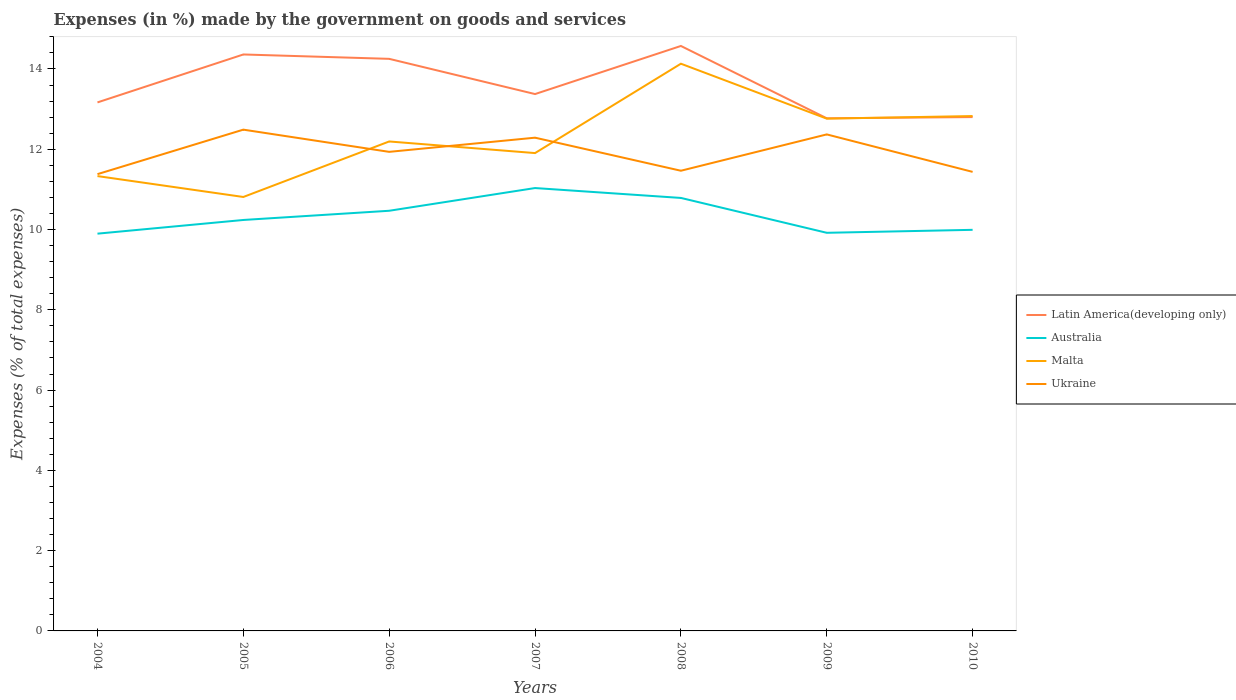How many different coloured lines are there?
Offer a terse response. 4. Does the line corresponding to Latin America(developing only) intersect with the line corresponding to Australia?
Offer a terse response. No. Across all years, what is the maximum percentage of expenses made by the government on goods and services in Australia?
Provide a short and direct response. 9.9. In which year was the percentage of expenses made by the government on goods and services in Malta maximum?
Ensure brevity in your answer.  2005. What is the total percentage of expenses made by the government on goods and services in Australia in the graph?
Provide a succinct answer. 0.79. What is the difference between the highest and the second highest percentage of expenses made by the government on goods and services in Latin America(developing only)?
Ensure brevity in your answer.  1.8. How many lines are there?
Your response must be concise. 4. Where does the legend appear in the graph?
Make the answer very short. Center right. What is the title of the graph?
Make the answer very short. Expenses (in %) made by the government on goods and services. Does "Antigua and Barbuda" appear as one of the legend labels in the graph?
Keep it short and to the point. No. What is the label or title of the X-axis?
Provide a succinct answer. Years. What is the label or title of the Y-axis?
Your answer should be very brief. Expenses (% of total expenses). What is the Expenses (% of total expenses) of Latin America(developing only) in 2004?
Provide a succinct answer. 13.17. What is the Expenses (% of total expenses) in Australia in 2004?
Make the answer very short. 9.9. What is the Expenses (% of total expenses) of Malta in 2004?
Your answer should be very brief. 11.33. What is the Expenses (% of total expenses) of Ukraine in 2004?
Give a very brief answer. 11.38. What is the Expenses (% of total expenses) of Latin America(developing only) in 2005?
Offer a very short reply. 14.36. What is the Expenses (% of total expenses) in Australia in 2005?
Your answer should be compact. 10.24. What is the Expenses (% of total expenses) of Malta in 2005?
Offer a very short reply. 10.81. What is the Expenses (% of total expenses) of Ukraine in 2005?
Ensure brevity in your answer.  12.49. What is the Expenses (% of total expenses) in Latin America(developing only) in 2006?
Provide a short and direct response. 14.25. What is the Expenses (% of total expenses) in Australia in 2006?
Your response must be concise. 10.47. What is the Expenses (% of total expenses) of Malta in 2006?
Offer a very short reply. 12.19. What is the Expenses (% of total expenses) of Ukraine in 2006?
Give a very brief answer. 11.94. What is the Expenses (% of total expenses) of Latin America(developing only) in 2007?
Ensure brevity in your answer.  13.38. What is the Expenses (% of total expenses) of Australia in 2007?
Your answer should be compact. 11.03. What is the Expenses (% of total expenses) in Malta in 2007?
Provide a succinct answer. 11.91. What is the Expenses (% of total expenses) of Ukraine in 2007?
Your answer should be compact. 12.29. What is the Expenses (% of total expenses) of Latin America(developing only) in 2008?
Your answer should be compact. 14.57. What is the Expenses (% of total expenses) in Australia in 2008?
Ensure brevity in your answer.  10.79. What is the Expenses (% of total expenses) of Malta in 2008?
Your answer should be compact. 14.13. What is the Expenses (% of total expenses) in Ukraine in 2008?
Make the answer very short. 11.47. What is the Expenses (% of total expenses) in Latin America(developing only) in 2009?
Give a very brief answer. 12.77. What is the Expenses (% of total expenses) of Australia in 2009?
Offer a very short reply. 9.92. What is the Expenses (% of total expenses) of Malta in 2009?
Offer a terse response. 12.76. What is the Expenses (% of total expenses) in Ukraine in 2009?
Give a very brief answer. 12.37. What is the Expenses (% of total expenses) in Latin America(developing only) in 2010?
Your response must be concise. 12.8. What is the Expenses (% of total expenses) of Australia in 2010?
Your response must be concise. 9.99. What is the Expenses (% of total expenses) of Malta in 2010?
Your answer should be compact. 12.83. What is the Expenses (% of total expenses) in Ukraine in 2010?
Keep it short and to the point. 11.44. Across all years, what is the maximum Expenses (% of total expenses) of Latin America(developing only)?
Your response must be concise. 14.57. Across all years, what is the maximum Expenses (% of total expenses) in Australia?
Offer a terse response. 11.03. Across all years, what is the maximum Expenses (% of total expenses) in Malta?
Ensure brevity in your answer.  14.13. Across all years, what is the maximum Expenses (% of total expenses) of Ukraine?
Your answer should be compact. 12.49. Across all years, what is the minimum Expenses (% of total expenses) of Latin America(developing only)?
Give a very brief answer. 12.77. Across all years, what is the minimum Expenses (% of total expenses) in Australia?
Keep it short and to the point. 9.9. Across all years, what is the minimum Expenses (% of total expenses) in Malta?
Provide a succinct answer. 10.81. Across all years, what is the minimum Expenses (% of total expenses) of Ukraine?
Provide a succinct answer. 11.38. What is the total Expenses (% of total expenses) of Latin America(developing only) in the graph?
Give a very brief answer. 95.3. What is the total Expenses (% of total expenses) of Australia in the graph?
Offer a terse response. 72.34. What is the total Expenses (% of total expenses) of Malta in the graph?
Make the answer very short. 85.96. What is the total Expenses (% of total expenses) in Ukraine in the graph?
Your response must be concise. 83.36. What is the difference between the Expenses (% of total expenses) of Latin America(developing only) in 2004 and that in 2005?
Offer a very short reply. -1.19. What is the difference between the Expenses (% of total expenses) in Australia in 2004 and that in 2005?
Provide a short and direct response. -0.34. What is the difference between the Expenses (% of total expenses) in Malta in 2004 and that in 2005?
Your answer should be very brief. 0.52. What is the difference between the Expenses (% of total expenses) in Ukraine in 2004 and that in 2005?
Offer a terse response. -1.11. What is the difference between the Expenses (% of total expenses) of Latin America(developing only) in 2004 and that in 2006?
Give a very brief answer. -1.09. What is the difference between the Expenses (% of total expenses) of Australia in 2004 and that in 2006?
Offer a terse response. -0.57. What is the difference between the Expenses (% of total expenses) of Malta in 2004 and that in 2006?
Your answer should be compact. -0.86. What is the difference between the Expenses (% of total expenses) of Ukraine in 2004 and that in 2006?
Your answer should be very brief. -0.56. What is the difference between the Expenses (% of total expenses) of Latin America(developing only) in 2004 and that in 2007?
Offer a very short reply. -0.21. What is the difference between the Expenses (% of total expenses) in Australia in 2004 and that in 2007?
Give a very brief answer. -1.14. What is the difference between the Expenses (% of total expenses) of Malta in 2004 and that in 2007?
Provide a short and direct response. -0.57. What is the difference between the Expenses (% of total expenses) in Ukraine in 2004 and that in 2007?
Provide a short and direct response. -0.91. What is the difference between the Expenses (% of total expenses) in Latin America(developing only) in 2004 and that in 2008?
Make the answer very short. -1.41. What is the difference between the Expenses (% of total expenses) of Australia in 2004 and that in 2008?
Your answer should be compact. -0.89. What is the difference between the Expenses (% of total expenses) of Malta in 2004 and that in 2008?
Your answer should be very brief. -2.8. What is the difference between the Expenses (% of total expenses) in Ukraine in 2004 and that in 2008?
Ensure brevity in your answer.  -0.09. What is the difference between the Expenses (% of total expenses) of Latin America(developing only) in 2004 and that in 2009?
Give a very brief answer. 0.4. What is the difference between the Expenses (% of total expenses) of Australia in 2004 and that in 2009?
Offer a very short reply. -0.02. What is the difference between the Expenses (% of total expenses) of Malta in 2004 and that in 2009?
Give a very brief answer. -1.43. What is the difference between the Expenses (% of total expenses) in Ukraine in 2004 and that in 2009?
Your response must be concise. -0.99. What is the difference between the Expenses (% of total expenses) of Latin America(developing only) in 2004 and that in 2010?
Offer a terse response. 0.37. What is the difference between the Expenses (% of total expenses) of Australia in 2004 and that in 2010?
Offer a very short reply. -0.1. What is the difference between the Expenses (% of total expenses) of Malta in 2004 and that in 2010?
Offer a terse response. -1.5. What is the difference between the Expenses (% of total expenses) in Ukraine in 2004 and that in 2010?
Your answer should be very brief. -0.06. What is the difference between the Expenses (% of total expenses) in Latin America(developing only) in 2005 and that in 2006?
Offer a very short reply. 0.11. What is the difference between the Expenses (% of total expenses) of Australia in 2005 and that in 2006?
Your answer should be very brief. -0.23. What is the difference between the Expenses (% of total expenses) of Malta in 2005 and that in 2006?
Offer a very short reply. -1.38. What is the difference between the Expenses (% of total expenses) in Ukraine in 2005 and that in 2006?
Provide a short and direct response. 0.55. What is the difference between the Expenses (% of total expenses) of Latin America(developing only) in 2005 and that in 2007?
Keep it short and to the point. 0.99. What is the difference between the Expenses (% of total expenses) of Australia in 2005 and that in 2007?
Offer a very short reply. -0.8. What is the difference between the Expenses (% of total expenses) in Malta in 2005 and that in 2007?
Offer a very short reply. -1.09. What is the difference between the Expenses (% of total expenses) in Ukraine in 2005 and that in 2007?
Offer a terse response. 0.2. What is the difference between the Expenses (% of total expenses) in Latin America(developing only) in 2005 and that in 2008?
Your response must be concise. -0.21. What is the difference between the Expenses (% of total expenses) of Australia in 2005 and that in 2008?
Provide a succinct answer. -0.55. What is the difference between the Expenses (% of total expenses) in Malta in 2005 and that in 2008?
Provide a succinct answer. -3.32. What is the difference between the Expenses (% of total expenses) of Ukraine in 2005 and that in 2008?
Provide a short and direct response. 1.02. What is the difference between the Expenses (% of total expenses) of Latin America(developing only) in 2005 and that in 2009?
Provide a succinct answer. 1.59. What is the difference between the Expenses (% of total expenses) of Australia in 2005 and that in 2009?
Offer a terse response. 0.32. What is the difference between the Expenses (% of total expenses) in Malta in 2005 and that in 2009?
Make the answer very short. -1.95. What is the difference between the Expenses (% of total expenses) of Ukraine in 2005 and that in 2009?
Provide a short and direct response. 0.12. What is the difference between the Expenses (% of total expenses) in Latin America(developing only) in 2005 and that in 2010?
Offer a terse response. 1.56. What is the difference between the Expenses (% of total expenses) in Australia in 2005 and that in 2010?
Provide a short and direct response. 0.25. What is the difference between the Expenses (% of total expenses) in Malta in 2005 and that in 2010?
Your answer should be very brief. -2.02. What is the difference between the Expenses (% of total expenses) of Ukraine in 2005 and that in 2010?
Make the answer very short. 1.05. What is the difference between the Expenses (% of total expenses) of Latin America(developing only) in 2006 and that in 2007?
Your answer should be compact. 0.88. What is the difference between the Expenses (% of total expenses) of Australia in 2006 and that in 2007?
Keep it short and to the point. -0.57. What is the difference between the Expenses (% of total expenses) of Malta in 2006 and that in 2007?
Provide a succinct answer. 0.29. What is the difference between the Expenses (% of total expenses) of Ukraine in 2006 and that in 2007?
Offer a terse response. -0.35. What is the difference between the Expenses (% of total expenses) of Latin America(developing only) in 2006 and that in 2008?
Provide a short and direct response. -0.32. What is the difference between the Expenses (% of total expenses) of Australia in 2006 and that in 2008?
Make the answer very short. -0.32. What is the difference between the Expenses (% of total expenses) of Malta in 2006 and that in 2008?
Ensure brevity in your answer.  -1.94. What is the difference between the Expenses (% of total expenses) of Ukraine in 2006 and that in 2008?
Provide a short and direct response. 0.47. What is the difference between the Expenses (% of total expenses) of Latin America(developing only) in 2006 and that in 2009?
Provide a short and direct response. 1.48. What is the difference between the Expenses (% of total expenses) in Australia in 2006 and that in 2009?
Ensure brevity in your answer.  0.55. What is the difference between the Expenses (% of total expenses) of Malta in 2006 and that in 2009?
Your answer should be compact. -0.57. What is the difference between the Expenses (% of total expenses) in Ukraine in 2006 and that in 2009?
Keep it short and to the point. -0.43. What is the difference between the Expenses (% of total expenses) of Latin America(developing only) in 2006 and that in 2010?
Ensure brevity in your answer.  1.45. What is the difference between the Expenses (% of total expenses) of Australia in 2006 and that in 2010?
Offer a very short reply. 0.47. What is the difference between the Expenses (% of total expenses) of Malta in 2006 and that in 2010?
Your response must be concise. -0.63. What is the difference between the Expenses (% of total expenses) of Ukraine in 2006 and that in 2010?
Offer a terse response. 0.5. What is the difference between the Expenses (% of total expenses) in Latin America(developing only) in 2007 and that in 2008?
Offer a terse response. -1.2. What is the difference between the Expenses (% of total expenses) in Australia in 2007 and that in 2008?
Your answer should be compact. 0.25. What is the difference between the Expenses (% of total expenses) of Malta in 2007 and that in 2008?
Provide a short and direct response. -2.23. What is the difference between the Expenses (% of total expenses) in Ukraine in 2007 and that in 2008?
Provide a short and direct response. 0.82. What is the difference between the Expenses (% of total expenses) of Latin America(developing only) in 2007 and that in 2009?
Make the answer very short. 0.6. What is the difference between the Expenses (% of total expenses) of Australia in 2007 and that in 2009?
Your response must be concise. 1.12. What is the difference between the Expenses (% of total expenses) of Malta in 2007 and that in 2009?
Offer a very short reply. -0.86. What is the difference between the Expenses (% of total expenses) of Ukraine in 2007 and that in 2009?
Offer a terse response. -0.08. What is the difference between the Expenses (% of total expenses) of Latin America(developing only) in 2007 and that in 2010?
Your answer should be compact. 0.57. What is the difference between the Expenses (% of total expenses) in Australia in 2007 and that in 2010?
Your answer should be compact. 1.04. What is the difference between the Expenses (% of total expenses) of Malta in 2007 and that in 2010?
Your response must be concise. -0.92. What is the difference between the Expenses (% of total expenses) in Ukraine in 2007 and that in 2010?
Provide a succinct answer. 0.85. What is the difference between the Expenses (% of total expenses) in Latin America(developing only) in 2008 and that in 2009?
Make the answer very short. 1.8. What is the difference between the Expenses (% of total expenses) in Australia in 2008 and that in 2009?
Keep it short and to the point. 0.87. What is the difference between the Expenses (% of total expenses) of Malta in 2008 and that in 2009?
Make the answer very short. 1.37. What is the difference between the Expenses (% of total expenses) of Ukraine in 2008 and that in 2009?
Offer a terse response. -0.91. What is the difference between the Expenses (% of total expenses) of Latin America(developing only) in 2008 and that in 2010?
Offer a terse response. 1.77. What is the difference between the Expenses (% of total expenses) in Australia in 2008 and that in 2010?
Your response must be concise. 0.79. What is the difference between the Expenses (% of total expenses) in Malta in 2008 and that in 2010?
Your answer should be very brief. 1.3. What is the difference between the Expenses (% of total expenses) in Ukraine in 2008 and that in 2010?
Your response must be concise. 0.03. What is the difference between the Expenses (% of total expenses) of Latin America(developing only) in 2009 and that in 2010?
Make the answer very short. -0.03. What is the difference between the Expenses (% of total expenses) of Australia in 2009 and that in 2010?
Ensure brevity in your answer.  -0.07. What is the difference between the Expenses (% of total expenses) in Malta in 2009 and that in 2010?
Ensure brevity in your answer.  -0.06. What is the difference between the Expenses (% of total expenses) in Ukraine in 2009 and that in 2010?
Ensure brevity in your answer.  0.93. What is the difference between the Expenses (% of total expenses) of Latin America(developing only) in 2004 and the Expenses (% of total expenses) of Australia in 2005?
Your answer should be compact. 2.93. What is the difference between the Expenses (% of total expenses) of Latin America(developing only) in 2004 and the Expenses (% of total expenses) of Malta in 2005?
Offer a very short reply. 2.36. What is the difference between the Expenses (% of total expenses) of Latin America(developing only) in 2004 and the Expenses (% of total expenses) of Ukraine in 2005?
Keep it short and to the point. 0.68. What is the difference between the Expenses (% of total expenses) in Australia in 2004 and the Expenses (% of total expenses) in Malta in 2005?
Your answer should be compact. -0.91. What is the difference between the Expenses (% of total expenses) in Australia in 2004 and the Expenses (% of total expenses) in Ukraine in 2005?
Your answer should be compact. -2.59. What is the difference between the Expenses (% of total expenses) of Malta in 2004 and the Expenses (% of total expenses) of Ukraine in 2005?
Keep it short and to the point. -1.16. What is the difference between the Expenses (% of total expenses) of Latin America(developing only) in 2004 and the Expenses (% of total expenses) of Australia in 2006?
Offer a terse response. 2.7. What is the difference between the Expenses (% of total expenses) in Latin America(developing only) in 2004 and the Expenses (% of total expenses) in Malta in 2006?
Ensure brevity in your answer.  0.97. What is the difference between the Expenses (% of total expenses) in Latin America(developing only) in 2004 and the Expenses (% of total expenses) in Ukraine in 2006?
Your answer should be very brief. 1.23. What is the difference between the Expenses (% of total expenses) in Australia in 2004 and the Expenses (% of total expenses) in Malta in 2006?
Make the answer very short. -2.3. What is the difference between the Expenses (% of total expenses) of Australia in 2004 and the Expenses (% of total expenses) of Ukraine in 2006?
Give a very brief answer. -2.04. What is the difference between the Expenses (% of total expenses) of Malta in 2004 and the Expenses (% of total expenses) of Ukraine in 2006?
Your answer should be compact. -0.6. What is the difference between the Expenses (% of total expenses) of Latin America(developing only) in 2004 and the Expenses (% of total expenses) of Australia in 2007?
Your response must be concise. 2.13. What is the difference between the Expenses (% of total expenses) of Latin America(developing only) in 2004 and the Expenses (% of total expenses) of Malta in 2007?
Give a very brief answer. 1.26. What is the difference between the Expenses (% of total expenses) in Latin America(developing only) in 2004 and the Expenses (% of total expenses) in Ukraine in 2007?
Keep it short and to the point. 0.88. What is the difference between the Expenses (% of total expenses) in Australia in 2004 and the Expenses (% of total expenses) in Malta in 2007?
Make the answer very short. -2.01. What is the difference between the Expenses (% of total expenses) in Australia in 2004 and the Expenses (% of total expenses) in Ukraine in 2007?
Offer a terse response. -2.39. What is the difference between the Expenses (% of total expenses) in Malta in 2004 and the Expenses (% of total expenses) in Ukraine in 2007?
Your answer should be compact. -0.96. What is the difference between the Expenses (% of total expenses) of Latin America(developing only) in 2004 and the Expenses (% of total expenses) of Australia in 2008?
Keep it short and to the point. 2.38. What is the difference between the Expenses (% of total expenses) of Latin America(developing only) in 2004 and the Expenses (% of total expenses) of Malta in 2008?
Make the answer very short. -0.96. What is the difference between the Expenses (% of total expenses) of Latin America(developing only) in 2004 and the Expenses (% of total expenses) of Ukraine in 2008?
Your answer should be compact. 1.7. What is the difference between the Expenses (% of total expenses) in Australia in 2004 and the Expenses (% of total expenses) in Malta in 2008?
Provide a short and direct response. -4.23. What is the difference between the Expenses (% of total expenses) in Australia in 2004 and the Expenses (% of total expenses) in Ukraine in 2008?
Your answer should be very brief. -1.57. What is the difference between the Expenses (% of total expenses) in Malta in 2004 and the Expenses (% of total expenses) in Ukraine in 2008?
Make the answer very short. -0.13. What is the difference between the Expenses (% of total expenses) of Latin America(developing only) in 2004 and the Expenses (% of total expenses) of Australia in 2009?
Offer a very short reply. 3.25. What is the difference between the Expenses (% of total expenses) of Latin America(developing only) in 2004 and the Expenses (% of total expenses) of Malta in 2009?
Offer a very short reply. 0.4. What is the difference between the Expenses (% of total expenses) of Latin America(developing only) in 2004 and the Expenses (% of total expenses) of Ukraine in 2009?
Your answer should be compact. 0.8. What is the difference between the Expenses (% of total expenses) of Australia in 2004 and the Expenses (% of total expenses) of Malta in 2009?
Your answer should be compact. -2.87. What is the difference between the Expenses (% of total expenses) of Australia in 2004 and the Expenses (% of total expenses) of Ukraine in 2009?
Provide a short and direct response. -2.47. What is the difference between the Expenses (% of total expenses) of Malta in 2004 and the Expenses (% of total expenses) of Ukraine in 2009?
Keep it short and to the point. -1.04. What is the difference between the Expenses (% of total expenses) in Latin America(developing only) in 2004 and the Expenses (% of total expenses) in Australia in 2010?
Offer a terse response. 3.17. What is the difference between the Expenses (% of total expenses) in Latin America(developing only) in 2004 and the Expenses (% of total expenses) in Malta in 2010?
Your response must be concise. 0.34. What is the difference between the Expenses (% of total expenses) of Latin America(developing only) in 2004 and the Expenses (% of total expenses) of Ukraine in 2010?
Give a very brief answer. 1.73. What is the difference between the Expenses (% of total expenses) of Australia in 2004 and the Expenses (% of total expenses) of Malta in 2010?
Provide a succinct answer. -2.93. What is the difference between the Expenses (% of total expenses) of Australia in 2004 and the Expenses (% of total expenses) of Ukraine in 2010?
Keep it short and to the point. -1.54. What is the difference between the Expenses (% of total expenses) of Malta in 2004 and the Expenses (% of total expenses) of Ukraine in 2010?
Your response must be concise. -0.1. What is the difference between the Expenses (% of total expenses) of Latin America(developing only) in 2005 and the Expenses (% of total expenses) of Australia in 2006?
Your answer should be very brief. 3.89. What is the difference between the Expenses (% of total expenses) of Latin America(developing only) in 2005 and the Expenses (% of total expenses) of Malta in 2006?
Provide a short and direct response. 2.17. What is the difference between the Expenses (% of total expenses) of Latin America(developing only) in 2005 and the Expenses (% of total expenses) of Ukraine in 2006?
Provide a succinct answer. 2.43. What is the difference between the Expenses (% of total expenses) in Australia in 2005 and the Expenses (% of total expenses) in Malta in 2006?
Provide a short and direct response. -1.96. What is the difference between the Expenses (% of total expenses) of Australia in 2005 and the Expenses (% of total expenses) of Ukraine in 2006?
Ensure brevity in your answer.  -1.7. What is the difference between the Expenses (% of total expenses) of Malta in 2005 and the Expenses (% of total expenses) of Ukraine in 2006?
Your answer should be compact. -1.12. What is the difference between the Expenses (% of total expenses) in Latin America(developing only) in 2005 and the Expenses (% of total expenses) in Australia in 2007?
Your answer should be very brief. 3.33. What is the difference between the Expenses (% of total expenses) in Latin America(developing only) in 2005 and the Expenses (% of total expenses) in Malta in 2007?
Offer a very short reply. 2.46. What is the difference between the Expenses (% of total expenses) of Latin America(developing only) in 2005 and the Expenses (% of total expenses) of Ukraine in 2007?
Offer a terse response. 2.07. What is the difference between the Expenses (% of total expenses) in Australia in 2005 and the Expenses (% of total expenses) in Malta in 2007?
Provide a short and direct response. -1.67. What is the difference between the Expenses (% of total expenses) in Australia in 2005 and the Expenses (% of total expenses) in Ukraine in 2007?
Ensure brevity in your answer.  -2.05. What is the difference between the Expenses (% of total expenses) in Malta in 2005 and the Expenses (% of total expenses) in Ukraine in 2007?
Provide a short and direct response. -1.48. What is the difference between the Expenses (% of total expenses) in Latin America(developing only) in 2005 and the Expenses (% of total expenses) in Australia in 2008?
Your response must be concise. 3.57. What is the difference between the Expenses (% of total expenses) in Latin America(developing only) in 2005 and the Expenses (% of total expenses) in Malta in 2008?
Offer a very short reply. 0.23. What is the difference between the Expenses (% of total expenses) of Latin America(developing only) in 2005 and the Expenses (% of total expenses) of Ukraine in 2008?
Make the answer very short. 2.9. What is the difference between the Expenses (% of total expenses) of Australia in 2005 and the Expenses (% of total expenses) of Malta in 2008?
Ensure brevity in your answer.  -3.89. What is the difference between the Expenses (% of total expenses) of Australia in 2005 and the Expenses (% of total expenses) of Ukraine in 2008?
Provide a succinct answer. -1.23. What is the difference between the Expenses (% of total expenses) of Malta in 2005 and the Expenses (% of total expenses) of Ukraine in 2008?
Give a very brief answer. -0.65. What is the difference between the Expenses (% of total expenses) in Latin America(developing only) in 2005 and the Expenses (% of total expenses) in Australia in 2009?
Ensure brevity in your answer.  4.44. What is the difference between the Expenses (% of total expenses) of Latin America(developing only) in 2005 and the Expenses (% of total expenses) of Malta in 2009?
Provide a short and direct response. 1.6. What is the difference between the Expenses (% of total expenses) in Latin America(developing only) in 2005 and the Expenses (% of total expenses) in Ukraine in 2009?
Make the answer very short. 1.99. What is the difference between the Expenses (% of total expenses) in Australia in 2005 and the Expenses (% of total expenses) in Malta in 2009?
Offer a very short reply. -2.52. What is the difference between the Expenses (% of total expenses) of Australia in 2005 and the Expenses (% of total expenses) of Ukraine in 2009?
Your answer should be compact. -2.13. What is the difference between the Expenses (% of total expenses) of Malta in 2005 and the Expenses (% of total expenses) of Ukraine in 2009?
Offer a terse response. -1.56. What is the difference between the Expenses (% of total expenses) of Latin America(developing only) in 2005 and the Expenses (% of total expenses) of Australia in 2010?
Your response must be concise. 4.37. What is the difference between the Expenses (% of total expenses) of Latin America(developing only) in 2005 and the Expenses (% of total expenses) of Malta in 2010?
Ensure brevity in your answer.  1.53. What is the difference between the Expenses (% of total expenses) in Latin America(developing only) in 2005 and the Expenses (% of total expenses) in Ukraine in 2010?
Ensure brevity in your answer.  2.93. What is the difference between the Expenses (% of total expenses) of Australia in 2005 and the Expenses (% of total expenses) of Malta in 2010?
Your answer should be compact. -2.59. What is the difference between the Expenses (% of total expenses) of Australia in 2005 and the Expenses (% of total expenses) of Ukraine in 2010?
Give a very brief answer. -1.2. What is the difference between the Expenses (% of total expenses) in Malta in 2005 and the Expenses (% of total expenses) in Ukraine in 2010?
Offer a very short reply. -0.63. What is the difference between the Expenses (% of total expenses) in Latin America(developing only) in 2006 and the Expenses (% of total expenses) in Australia in 2007?
Keep it short and to the point. 3.22. What is the difference between the Expenses (% of total expenses) of Latin America(developing only) in 2006 and the Expenses (% of total expenses) of Malta in 2007?
Provide a short and direct response. 2.35. What is the difference between the Expenses (% of total expenses) in Latin America(developing only) in 2006 and the Expenses (% of total expenses) in Ukraine in 2007?
Keep it short and to the point. 1.96. What is the difference between the Expenses (% of total expenses) of Australia in 2006 and the Expenses (% of total expenses) of Malta in 2007?
Provide a short and direct response. -1.44. What is the difference between the Expenses (% of total expenses) of Australia in 2006 and the Expenses (% of total expenses) of Ukraine in 2007?
Offer a very short reply. -1.82. What is the difference between the Expenses (% of total expenses) of Malta in 2006 and the Expenses (% of total expenses) of Ukraine in 2007?
Offer a very short reply. -0.09. What is the difference between the Expenses (% of total expenses) of Latin America(developing only) in 2006 and the Expenses (% of total expenses) of Australia in 2008?
Make the answer very short. 3.47. What is the difference between the Expenses (% of total expenses) in Latin America(developing only) in 2006 and the Expenses (% of total expenses) in Malta in 2008?
Give a very brief answer. 0.12. What is the difference between the Expenses (% of total expenses) of Latin America(developing only) in 2006 and the Expenses (% of total expenses) of Ukraine in 2008?
Offer a terse response. 2.79. What is the difference between the Expenses (% of total expenses) in Australia in 2006 and the Expenses (% of total expenses) in Malta in 2008?
Your answer should be very brief. -3.66. What is the difference between the Expenses (% of total expenses) of Australia in 2006 and the Expenses (% of total expenses) of Ukraine in 2008?
Offer a terse response. -1. What is the difference between the Expenses (% of total expenses) in Malta in 2006 and the Expenses (% of total expenses) in Ukraine in 2008?
Your answer should be compact. 0.73. What is the difference between the Expenses (% of total expenses) in Latin America(developing only) in 2006 and the Expenses (% of total expenses) in Australia in 2009?
Offer a terse response. 4.33. What is the difference between the Expenses (% of total expenses) in Latin America(developing only) in 2006 and the Expenses (% of total expenses) in Malta in 2009?
Give a very brief answer. 1.49. What is the difference between the Expenses (% of total expenses) in Latin America(developing only) in 2006 and the Expenses (% of total expenses) in Ukraine in 2009?
Give a very brief answer. 1.88. What is the difference between the Expenses (% of total expenses) of Australia in 2006 and the Expenses (% of total expenses) of Malta in 2009?
Provide a succinct answer. -2.3. What is the difference between the Expenses (% of total expenses) in Australia in 2006 and the Expenses (% of total expenses) in Ukraine in 2009?
Offer a terse response. -1.9. What is the difference between the Expenses (% of total expenses) of Malta in 2006 and the Expenses (% of total expenses) of Ukraine in 2009?
Your answer should be compact. -0.18. What is the difference between the Expenses (% of total expenses) of Latin America(developing only) in 2006 and the Expenses (% of total expenses) of Australia in 2010?
Your response must be concise. 4.26. What is the difference between the Expenses (% of total expenses) of Latin America(developing only) in 2006 and the Expenses (% of total expenses) of Malta in 2010?
Offer a very short reply. 1.43. What is the difference between the Expenses (% of total expenses) of Latin America(developing only) in 2006 and the Expenses (% of total expenses) of Ukraine in 2010?
Ensure brevity in your answer.  2.82. What is the difference between the Expenses (% of total expenses) in Australia in 2006 and the Expenses (% of total expenses) in Malta in 2010?
Keep it short and to the point. -2.36. What is the difference between the Expenses (% of total expenses) in Australia in 2006 and the Expenses (% of total expenses) in Ukraine in 2010?
Provide a succinct answer. -0.97. What is the difference between the Expenses (% of total expenses) of Malta in 2006 and the Expenses (% of total expenses) of Ukraine in 2010?
Your answer should be compact. 0.76. What is the difference between the Expenses (% of total expenses) in Latin America(developing only) in 2007 and the Expenses (% of total expenses) in Australia in 2008?
Give a very brief answer. 2.59. What is the difference between the Expenses (% of total expenses) of Latin America(developing only) in 2007 and the Expenses (% of total expenses) of Malta in 2008?
Offer a very short reply. -0.76. What is the difference between the Expenses (% of total expenses) in Latin America(developing only) in 2007 and the Expenses (% of total expenses) in Ukraine in 2008?
Provide a succinct answer. 1.91. What is the difference between the Expenses (% of total expenses) of Australia in 2007 and the Expenses (% of total expenses) of Malta in 2008?
Offer a terse response. -3.1. What is the difference between the Expenses (% of total expenses) in Australia in 2007 and the Expenses (% of total expenses) in Ukraine in 2008?
Offer a very short reply. -0.43. What is the difference between the Expenses (% of total expenses) of Malta in 2007 and the Expenses (% of total expenses) of Ukraine in 2008?
Offer a very short reply. 0.44. What is the difference between the Expenses (% of total expenses) of Latin America(developing only) in 2007 and the Expenses (% of total expenses) of Australia in 2009?
Provide a succinct answer. 3.46. What is the difference between the Expenses (% of total expenses) in Latin America(developing only) in 2007 and the Expenses (% of total expenses) in Malta in 2009?
Your answer should be very brief. 0.61. What is the difference between the Expenses (% of total expenses) in Australia in 2007 and the Expenses (% of total expenses) in Malta in 2009?
Keep it short and to the point. -1.73. What is the difference between the Expenses (% of total expenses) in Australia in 2007 and the Expenses (% of total expenses) in Ukraine in 2009?
Your answer should be compact. -1.34. What is the difference between the Expenses (% of total expenses) of Malta in 2007 and the Expenses (% of total expenses) of Ukraine in 2009?
Make the answer very short. -0.47. What is the difference between the Expenses (% of total expenses) in Latin America(developing only) in 2007 and the Expenses (% of total expenses) in Australia in 2010?
Give a very brief answer. 3.38. What is the difference between the Expenses (% of total expenses) of Latin America(developing only) in 2007 and the Expenses (% of total expenses) of Malta in 2010?
Keep it short and to the point. 0.55. What is the difference between the Expenses (% of total expenses) in Latin America(developing only) in 2007 and the Expenses (% of total expenses) in Ukraine in 2010?
Make the answer very short. 1.94. What is the difference between the Expenses (% of total expenses) of Australia in 2007 and the Expenses (% of total expenses) of Malta in 2010?
Keep it short and to the point. -1.79. What is the difference between the Expenses (% of total expenses) of Australia in 2007 and the Expenses (% of total expenses) of Ukraine in 2010?
Offer a very short reply. -0.4. What is the difference between the Expenses (% of total expenses) of Malta in 2007 and the Expenses (% of total expenses) of Ukraine in 2010?
Ensure brevity in your answer.  0.47. What is the difference between the Expenses (% of total expenses) of Latin America(developing only) in 2008 and the Expenses (% of total expenses) of Australia in 2009?
Provide a short and direct response. 4.66. What is the difference between the Expenses (% of total expenses) of Latin America(developing only) in 2008 and the Expenses (% of total expenses) of Malta in 2009?
Give a very brief answer. 1.81. What is the difference between the Expenses (% of total expenses) in Latin America(developing only) in 2008 and the Expenses (% of total expenses) in Ukraine in 2009?
Give a very brief answer. 2.2. What is the difference between the Expenses (% of total expenses) of Australia in 2008 and the Expenses (% of total expenses) of Malta in 2009?
Ensure brevity in your answer.  -1.98. What is the difference between the Expenses (% of total expenses) in Australia in 2008 and the Expenses (% of total expenses) in Ukraine in 2009?
Make the answer very short. -1.58. What is the difference between the Expenses (% of total expenses) in Malta in 2008 and the Expenses (% of total expenses) in Ukraine in 2009?
Ensure brevity in your answer.  1.76. What is the difference between the Expenses (% of total expenses) of Latin America(developing only) in 2008 and the Expenses (% of total expenses) of Australia in 2010?
Your answer should be compact. 4.58. What is the difference between the Expenses (% of total expenses) in Latin America(developing only) in 2008 and the Expenses (% of total expenses) in Malta in 2010?
Give a very brief answer. 1.75. What is the difference between the Expenses (% of total expenses) in Latin America(developing only) in 2008 and the Expenses (% of total expenses) in Ukraine in 2010?
Give a very brief answer. 3.14. What is the difference between the Expenses (% of total expenses) of Australia in 2008 and the Expenses (% of total expenses) of Malta in 2010?
Your answer should be compact. -2.04. What is the difference between the Expenses (% of total expenses) of Australia in 2008 and the Expenses (% of total expenses) of Ukraine in 2010?
Provide a short and direct response. -0.65. What is the difference between the Expenses (% of total expenses) of Malta in 2008 and the Expenses (% of total expenses) of Ukraine in 2010?
Your answer should be compact. 2.7. What is the difference between the Expenses (% of total expenses) in Latin America(developing only) in 2009 and the Expenses (% of total expenses) in Australia in 2010?
Your answer should be compact. 2.78. What is the difference between the Expenses (% of total expenses) of Latin America(developing only) in 2009 and the Expenses (% of total expenses) of Malta in 2010?
Your answer should be compact. -0.06. What is the difference between the Expenses (% of total expenses) in Latin America(developing only) in 2009 and the Expenses (% of total expenses) in Ukraine in 2010?
Make the answer very short. 1.34. What is the difference between the Expenses (% of total expenses) of Australia in 2009 and the Expenses (% of total expenses) of Malta in 2010?
Ensure brevity in your answer.  -2.91. What is the difference between the Expenses (% of total expenses) of Australia in 2009 and the Expenses (% of total expenses) of Ukraine in 2010?
Offer a very short reply. -1.52. What is the difference between the Expenses (% of total expenses) of Malta in 2009 and the Expenses (% of total expenses) of Ukraine in 2010?
Your answer should be very brief. 1.33. What is the average Expenses (% of total expenses) in Latin America(developing only) per year?
Give a very brief answer. 13.61. What is the average Expenses (% of total expenses) in Australia per year?
Make the answer very short. 10.33. What is the average Expenses (% of total expenses) of Malta per year?
Provide a short and direct response. 12.28. What is the average Expenses (% of total expenses) of Ukraine per year?
Keep it short and to the point. 11.91. In the year 2004, what is the difference between the Expenses (% of total expenses) in Latin America(developing only) and Expenses (% of total expenses) in Australia?
Keep it short and to the point. 3.27. In the year 2004, what is the difference between the Expenses (% of total expenses) of Latin America(developing only) and Expenses (% of total expenses) of Malta?
Give a very brief answer. 1.84. In the year 2004, what is the difference between the Expenses (% of total expenses) in Latin America(developing only) and Expenses (% of total expenses) in Ukraine?
Provide a short and direct response. 1.79. In the year 2004, what is the difference between the Expenses (% of total expenses) of Australia and Expenses (% of total expenses) of Malta?
Ensure brevity in your answer.  -1.43. In the year 2004, what is the difference between the Expenses (% of total expenses) of Australia and Expenses (% of total expenses) of Ukraine?
Your response must be concise. -1.48. In the year 2004, what is the difference between the Expenses (% of total expenses) in Malta and Expenses (% of total expenses) in Ukraine?
Provide a succinct answer. -0.05. In the year 2005, what is the difference between the Expenses (% of total expenses) in Latin America(developing only) and Expenses (% of total expenses) in Australia?
Your answer should be compact. 4.12. In the year 2005, what is the difference between the Expenses (% of total expenses) in Latin America(developing only) and Expenses (% of total expenses) in Malta?
Make the answer very short. 3.55. In the year 2005, what is the difference between the Expenses (% of total expenses) in Latin America(developing only) and Expenses (% of total expenses) in Ukraine?
Ensure brevity in your answer.  1.87. In the year 2005, what is the difference between the Expenses (% of total expenses) in Australia and Expenses (% of total expenses) in Malta?
Offer a very short reply. -0.57. In the year 2005, what is the difference between the Expenses (% of total expenses) in Australia and Expenses (% of total expenses) in Ukraine?
Your answer should be compact. -2.25. In the year 2005, what is the difference between the Expenses (% of total expenses) of Malta and Expenses (% of total expenses) of Ukraine?
Give a very brief answer. -1.68. In the year 2006, what is the difference between the Expenses (% of total expenses) in Latin America(developing only) and Expenses (% of total expenses) in Australia?
Your response must be concise. 3.79. In the year 2006, what is the difference between the Expenses (% of total expenses) in Latin America(developing only) and Expenses (% of total expenses) in Malta?
Your response must be concise. 2.06. In the year 2006, what is the difference between the Expenses (% of total expenses) in Latin America(developing only) and Expenses (% of total expenses) in Ukraine?
Your response must be concise. 2.32. In the year 2006, what is the difference between the Expenses (% of total expenses) of Australia and Expenses (% of total expenses) of Malta?
Ensure brevity in your answer.  -1.73. In the year 2006, what is the difference between the Expenses (% of total expenses) of Australia and Expenses (% of total expenses) of Ukraine?
Keep it short and to the point. -1.47. In the year 2006, what is the difference between the Expenses (% of total expenses) in Malta and Expenses (% of total expenses) in Ukraine?
Provide a short and direct response. 0.26. In the year 2007, what is the difference between the Expenses (% of total expenses) of Latin America(developing only) and Expenses (% of total expenses) of Australia?
Provide a short and direct response. 2.34. In the year 2007, what is the difference between the Expenses (% of total expenses) in Latin America(developing only) and Expenses (% of total expenses) in Malta?
Keep it short and to the point. 1.47. In the year 2007, what is the difference between the Expenses (% of total expenses) of Latin America(developing only) and Expenses (% of total expenses) of Ukraine?
Give a very brief answer. 1.09. In the year 2007, what is the difference between the Expenses (% of total expenses) of Australia and Expenses (% of total expenses) of Malta?
Offer a terse response. -0.87. In the year 2007, what is the difference between the Expenses (% of total expenses) in Australia and Expenses (% of total expenses) in Ukraine?
Provide a short and direct response. -1.25. In the year 2007, what is the difference between the Expenses (% of total expenses) of Malta and Expenses (% of total expenses) of Ukraine?
Your response must be concise. -0.38. In the year 2008, what is the difference between the Expenses (% of total expenses) in Latin America(developing only) and Expenses (% of total expenses) in Australia?
Your answer should be very brief. 3.79. In the year 2008, what is the difference between the Expenses (% of total expenses) in Latin America(developing only) and Expenses (% of total expenses) in Malta?
Keep it short and to the point. 0.44. In the year 2008, what is the difference between the Expenses (% of total expenses) in Latin America(developing only) and Expenses (% of total expenses) in Ukraine?
Keep it short and to the point. 3.11. In the year 2008, what is the difference between the Expenses (% of total expenses) in Australia and Expenses (% of total expenses) in Malta?
Your answer should be very brief. -3.34. In the year 2008, what is the difference between the Expenses (% of total expenses) in Australia and Expenses (% of total expenses) in Ukraine?
Provide a short and direct response. -0.68. In the year 2008, what is the difference between the Expenses (% of total expenses) of Malta and Expenses (% of total expenses) of Ukraine?
Your answer should be compact. 2.67. In the year 2009, what is the difference between the Expenses (% of total expenses) in Latin America(developing only) and Expenses (% of total expenses) in Australia?
Provide a short and direct response. 2.85. In the year 2009, what is the difference between the Expenses (% of total expenses) of Latin America(developing only) and Expenses (% of total expenses) of Malta?
Your answer should be very brief. 0.01. In the year 2009, what is the difference between the Expenses (% of total expenses) in Latin America(developing only) and Expenses (% of total expenses) in Ukraine?
Your response must be concise. 0.4. In the year 2009, what is the difference between the Expenses (% of total expenses) in Australia and Expenses (% of total expenses) in Malta?
Give a very brief answer. -2.84. In the year 2009, what is the difference between the Expenses (% of total expenses) of Australia and Expenses (% of total expenses) of Ukraine?
Give a very brief answer. -2.45. In the year 2009, what is the difference between the Expenses (% of total expenses) in Malta and Expenses (% of total expenses) in Ukraine?
Your answer should be very brief. 0.39. In the year 2010, what is the difference between the Expenses (% of total expenses) of Latin America(developing only) and Expenses (% of total expenses) of Australia?
Offer a terse response. 2.81. In the year 2010, what is the difference between the Expenses (% of total expenses) in Latin America(developing only) and Expenses (% of total expenses) in Malta?
Offer a terse response. -0.03. In the year 2010, what is the difference between the Expenses (% of total expenses) in Latin America(developing only) and Expenses (% of total expenses) in Ukraine?
Make the answer very short. 1.37. In the year 2010, what is the difference between the Expenses (% of total expenses) in Australia and Expenses (% of total expenses) in Malta?
Provide a short and direct response. -2.83. In the year 2010, what is the difference between the Expenses (% of total expenses) in Australia and Expenses (% of total expenses) in Ukraine?
Provide a short and direct response. -1.44. In the year 2010, what is the difference between the Expenses (% of total expenses) of Malta and Expenses (% of total expenses) of Ukraine?
Offer a terse response. 1.39. What is the ratio of the Expenses (% of total expenses) in Latin America(developing only) in 2004 to that in 2005?
Make the answer very short. 0.92. What is the ratio of the Expenses (% of total expenses) of Australia in 2004 to that in 2005?
Make the answer very short. 0.97. What is the ratio of the Expenses (% of total expenses) in Malta in 2004 to that in 2005?
Keep it short and to the point. 1.05. What is the ratio of the Expenses (% of total expenses) of Ukraine in 2004 to that in 2005?
Provide a short and direct response. 0.91. What is the ratio of the Expenses (% of total expenses) in Latin America(developing only) in 2004 to that in 2006?
Offer a very short reply. 0.92. What is the ratio of the Expenses (% of total expenses) of Australia in 2004 to that in 2006?
Provide a short and direct response. 0.95. What is the ratio of the Expenses (% of total expenses) in Malta in 2004 to that in 2006?
Offer a terse response. 0.93. What is the ratio of the Expenses (% of total expenses) in Ukraine in 2004 to that in 2006?
Your response must be concise. 0.95. What is the ratio of the Expenses (% of total expenses) in Latin America(developing only) in 2004 to that in 2007?
Offer a very short reply. 0.98. What is the ratio of the Expenses (% of total expenses) of Australia in 2004 to that in 2007?
Make the answer very short. 0.9. What is the ratio of the Expenses (% of total expenses) in Malta in 2004 to that in 2007?
Ensure brevity in your answer.  0.95. What is the ratio of the Expenses (% of total expenses) in Ukraine in 2004 to that in 2007?
Offer a terse response. 0.93. What is the ratio of the Expenses (% of total expenses) of Latin America(developing only) in 2004 to that in 2008?
Your answer should be compact. 0.9. What is the ratio of the Expenses (% of total expenses) of Australia in 2004 to that in 2008?
Ensure brevity in your answer.  0.92. What is the ratio of the Expenses (% of total expenses) in Malta in 2004 to that in 2008?
Your answer should be very brief. 0.8. What is the ratio of the Expenses (% of total expenses) of Ukraine in 2004 to that in 2008?
Your answer should be very brief. 0.99. What is the ratio of the Expenses (% of total expenses) of Latin America(developing only) in 2004 to that in 2009?
Offer a terse response. 1.03. What is the ratio of the Expenses (% of total expenses) of Australia in 2004 to that in 2009?
Provide a short and direct response. 1. What is the ratio of the Expenses (% of total expenses) in Malta in 2004 to that in 2009?
Keep it short and to the point. 0.89. What is the ratio of the Expenses (% of total expenses) in Ukraine in 2004 to that in 2009?
Your answer should be very brief. 0.92. What is the ratio of the Expenses (% of total expenses) of Latin America(developing only) in 2004 to that in 2010?
Offer a very short reply. 1.03. What is the ratio of the Expenses (% of total expenses) in Malta in 2004 to that in 2010?
Provide a short and direct response. 0.88. What is the ratio of the Expenses (% of total expenses) in Latin America(developing only) in 2005 to that in 2006?
Your answer should be very brief. 1.01. What is the ratio of the Expenses (% of total expenses) in Australia in 2005 to that in 2006?
Your response must be concise. 0.98. What is the ratio of the Expenses (% of total expenses) of Malta in 2005 to that in 2006?
Offer a very short reply. 0.89. What is the ratio of the Expenses (% of total expenses) in Ukraine in 2005 to that in 2006?
Provide a short and direct response. 1.05. What is the ratio of the Expenses (% of total expenses) of Latin America(developing only) in 2005 to that in 2007?
Keep it short and to the point. 1.07. What is the ratio of the Expenses (% of total expenses) in Australia in 2005 to that in 2007?
Offer a terse response. 0.93. What is the ratio of the Expenses (% of total expenses) of Malta in 2005 to that in 2007?
Give a very brief answer. 0.91. What is the ratio of the Expenses (% of total expenses) of Ukraine in 2005 to that in 2007?
Your answer should be very brief. 1.02. What is the ratio of the Expenses (% of total expenses) of Latin America(developing only) in 2005 to that in 2008?
Ensure brevity in your answer.  0.99. What is the ratio of the Expenses (% of total expenses) in Australia in 2005 to that in 2008?
Offer a very short reply. 0.95. What is the ratio of the Expenses (% of total expenses) in Malta in 2005 to that in 2008?
Your answer should be compact. 0.77. What is the ratio of the Expenses (% of total expenses) of Ukraine in 2005 to that in 2008?
Make the answer very short. 1.09. What is the ratio of the Expenses (% of total expenses) in Latin America(developing only) in 2005 to that in 2009?
Ensure brevity in your answer.  1.12. What is the ratio of the Expenses (% of total expenses) in Australia in 2005 to that in 2009?
Your response must be concise. 1.03. What is the ratio of the Expenses (% of total expenses) in Malta in 2005 to that in 2009?
Offer a terse response. 0.85. What is the ratio of the Expenses (% of total expenses) of Ukraine in 2005 to that in 2009?
Keep it short and to the point. 1.01. What is the ratio of the Expenses (% of total expenses) in Latin America(developing only) in 2005 to that in 2010?
Keep it short and to the point. 1.12. What is the ratio of the Expenses (% of total expenses) in Australia in 2005 to that in 2010?
Your answer should be very brief. 1.02. What is the ratio of the Expenses (% of total expenses) of Malta in 2005 to that in 2010?
Give a very brief answer. 0.84. What is the ratio of the Expenses (% of total expenses) of Ukraine in 2005 to that in 2010?
Provide a succinct answer. 1.09. What is the ratio of the Expenses (% of total expenses) in Latin America(developing only) in 2006 to that in 2007?
Give a very brief answer. 1.07. What is the ratio of the Expenses (% of total expenses) in Australia in 2006 to that in 2007?
Provide a succinct answer. 0.95. What is the ratio of the Expenses (% of total expenses) of Malta in 2006 to that in 2007?
Offer a very short reply. 1.02. What is the ratio of the Expenses (% of total expenses) of Ukraine in 2006 to that in 2007?
Offer a terse response. 0.97. What is the ratio of the Expenses (% of total expenses) in Latin America(developing only) in 2006 to that in 2008?
Your response must be concise. 0.98. What is the ratio of the Expenses (% of total expenses) in Australia in 2006 to that in 2008?
Your answer should be compact. 0.97. What is the ratio of the Expenses (% of total expenses) of Malta in 2006 to that in 2008?
Ensure brevity in your answer.  0.86. What is the ratio of the Expenses (% of total expenses) in Ukraine in 2006 to that in 2008?
Offer a terse response. 1.04. What is the ratio of the Expenses (% of total expenses) in Latin America(developing only) in 2006 to that in 2009?
Ensure brevity in your answer.  1.12. What is the ratio of the Expenses (% of total expenses) of Australia in 2006 to that in 2009?
Your answer should be compact. 1.06. What is the ratio of the Expenses (% of total expenses) in Malta in 2006 to that in 2009?
Your answer should be compact. 0.96. What is the ratio of the Expenses (% of total expenses) of Ukraine in 2006 to that in 2009?
Keep it short and to the point. 0.96. What is the ratio of the Expenses (% of total expenses) in Latin America(developing only) in 2006 to that in 2010?
Offer a terse response. 1.11. What is the ratio of the Expenses (% of total expenses) of Australia in 2006 to that in 2010?
Offer a very short reply. 1.05. What is the ratio of the Expenses (% of total expenses) in Malta in 2006 to that in 2010?
Give a very brief answer. 0.95. What is the ratio of the Expenses (% of total expenses) of Ukraine in 2006 to that in 2010?
Your answer should be very brief. 1.04. What is the ratio of the Expenses (% of total expenses) in Latin America(developing only) in 2007 to that in 2008?
Your answer should be compact. 0.92. What is the ratio of the Expenses (% of total expenses) of Australia in 2007 to that in 2008?
Your answer should be compact. 1.02. What is the ratio of the Expenses (% of total expenses) in Malta in 2007 to that in 2008?
Give a very brief answer. 0.84. What is the ratio of the Expenses (% of total expenses) of Ukraine in 2007 to that in 2008?
Keep it short and to the point. 1.07. What is the ratio of the Expenses (% of total expenses) of Latin America(developing only) in 2007 to that in 2009?
Provide a succinct answer. 1.05. What is the ratio of the Expenses (% of total expenses) in Australia in 2007 to that in 2009?
Your response must be concise. 1.11. What is the ratio of the Expenses (% of total expenses) in Malta in 2007 to that in 2009?
Ensure brevity in your answer.  0.93. What is the ratio of the Expenses (% of total expenses) in Ukraine in 2007 to that in 2009?
Your answer should be compact. 0.99. What is the ratio of the Expenses (% of total expenses) of Latin America(developing only) in 2007 to that in 2010?
Provide a short and direct response. 1.04. What is the ratio of the Expenses (% of total expenses) of Australia in 2007 to that in 2010?
Ensure brevity in your answer.  1.1. What is the ratio of the Expenses (% of total expenses) of Malta in 2007 to that in 2010?
Your answer should be compact. 0.93. What is the ratio of the Expenses (% of total expenses) of Ukraine in 2007 to that in 2010?
Provide a short and direct response. 1.07. What is the ratio of the Expenses (% of total expenses) of Latin America(developing only) in 2008 to that in 2009?
Make the answer very short. 1.14. What is the ratio of the Expenses (% of total expenses) in Australia in 2008 to that in 2009?
Keep it short and to the point. 1.09. What is the ratio of the Expenses (% of total expenses) of Malta in 2008 to that in 2009?
Offer a very short reply. 1.11. What is the ratio of the Expenses (% of total expenses) in Ukraine in 2008 to that in 2009?
Provide a short and direct response. 0.93. What is the ratio of the Expenses (% of total expenses) of Latin America(developing only) in 2008 to that in 2010?
Your answer should be compact. 1.14. What is the ratio of the Expenses (% of total expenses) of Australia in 2008 to that in 2010?
Give a very brief answer. 1.08. What is the ratio of the Expenses (% of total expenses) of Malta in 2008 to that in 2010?
Provide a short and direct response. 1.1. What is the ratio of the Expenses (% of total expenses) of Ukraine in 2008 to that in 2010?
Offer a terse response. 1. What is the ratio of the Expenses (% of total expenses) in Australia in 2009 to that in 2010?
Offer a very short reply. 0.99. What is the ratio of the Expenses (% of total expenses) in Malta in 2009 to that in 2010?
Your answer should be very brief. 0.99. What is the ratio of the Expenses (% of total expenses) in Ukraine in 2009 to that in 2010?
Your answer should be very brief. 1.08. What is the difference between the highest and the second highest Expenses (% of total expenses) in Latin America(developing only)?
Provide a succinct answer. 0.21. What is the difference between the highest and the second highest Expenses (% of total expenses) in Australia?
Keep it short and to the point. 0.25. What is the difference between the highest and the second highest Expenses (% of total expenses) in Malta?
Provide a succinct answer. 1.3. What is the difference between the highest and the second highest Expenses (% of total expenses) in Ukraine?
Offer a very short reply. 0.12. What is the difference between the highest and the lowest Expenses (% of total expenses) in Latin America(developing only)?
Keep it short and to the point. 1.8. What is the difference between the highest and the lowest Expenses (% of total expenses) of Australia?
Provide a short and direct response. 1.14. What is the difference between the highest and the lowest Expenses (% of total expenses) of Malta?
Your answer should be very brief. 3.32. What is the difference between the highest and the lowest Expenses (% of total expenses) of Ukraine?
Your response must be concise. 1.11. 